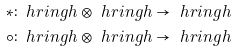<formula> <loc_0><loc_0><loc_500><loc_500>\ast & \colon \ h r i n g h \otimes \ h r i n g h \to \ h r i n g h \\ \circ & \colon \ h r i n g h \otimes \ h r i n g h \to \ h r i n g h</formula> 